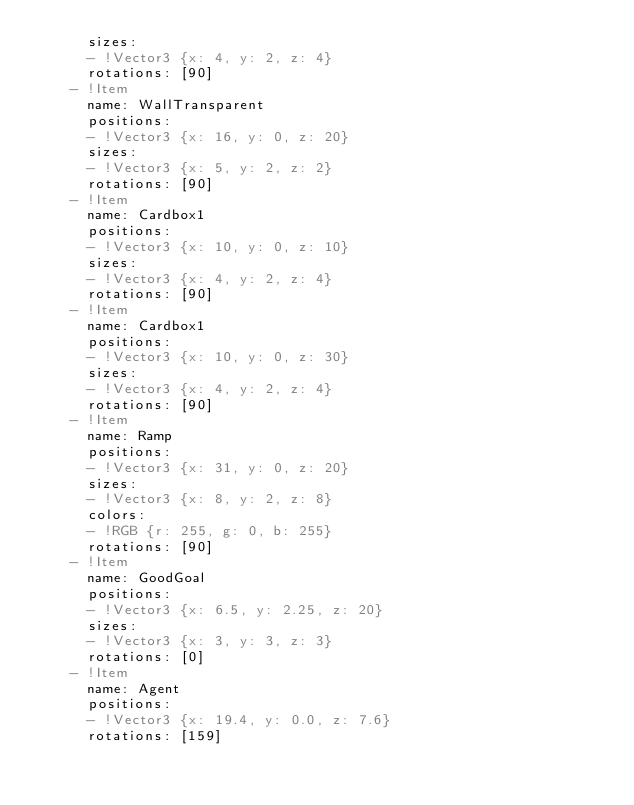<code> <loc_0><loc_0><loc_500><loc_500><_YAML_>      sizes: 
      - !Vector3 {x: 4, y: 2, z: 4}
      rotations: [90]
    - !Item 
      name: WallTransparent 
      positions: 
      - !Vector3 {x: 16, y: 0, z: 20}
      sizes: 
      - !Vector3 {x: 5, y: 2, z: 2}
      rotations: [90]
    - !Item 
      name: Cardbox1 
      positions: 
      - !Vector3 {x: 10, y: 0, z: 10}
      sizes: 
      - !Vector3 {x: 4, y: 2, z: 4}
      rotations: [90]
    - !Item 
      name: Cardbox1 
      positions: 
      - !Vector3 {x: 10, y: 0, z: 30}
      sizes: 
      - !Vector3 {x: 4, y: 2, z: 4}
      rotations: [90]
    - !Item 
      name: Ramp 
      positions: 
      - !Vector3 {x: 31, y: 0, z: 20}
      sizes: 
      - !Vector3 {x: 8, y: 2, z: 8}
      colors: 
      - !RGB {r: 255, g: 0, b: 255}
      rotations: [90]
    - !Item 
      name: GoodGoal 
      positions: 
      - !Vector3 {x: 6.5, y: 2.25, z: 20}
      sizes: 
      - !Vector3 {x: 3, y: 3, z: 3}
      rotations: [0]
    - !Item 
      name: Agent 
      positions: 
      - !Vector3 {x: 19.4, y: 0.0, z: 7.6}
      rotations: [159]
</code> 